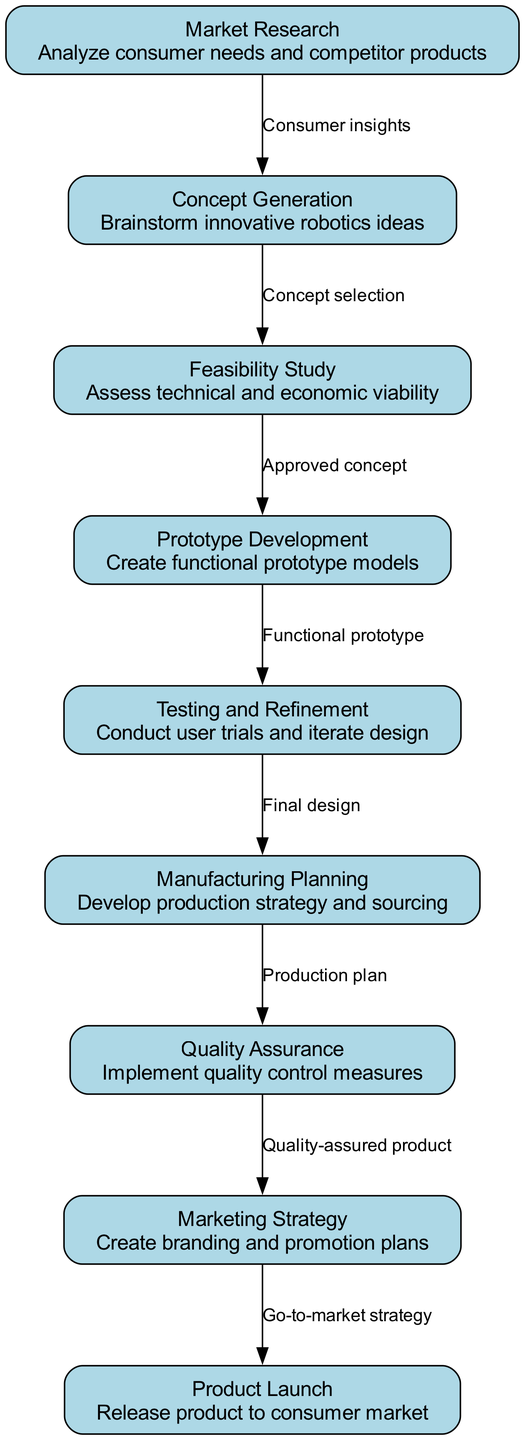What is the first stage of the development lifecycle? The diagram indicates that the first stage in the development lifecycle is labeled as "Market Research," which entails analyzing consumer needs and competitor products.
Answer: Market Research How many nodes are there in the diagram? By counting the individual nodes listed in the diagram, there are a total of 9 distinct nodes representing different stages in the development lifecycle of the consumer robotics product.
Answer: 9 What is the relationship between "Feasibility Study" and "Prototype Development"? The diagram shows a direct edge labeled "Approved concept" connecting "Feasibility Study" to "Prototype Development," indicating that the prototype development follows after an approved concept is established.
Answer: Approved concept Which node comes after "Testing and Refinement"? Following the flow in the diagram, "Testing and Refinement" is connected directly to "Manufacturing Planning," indicating that manufacturing planning occurs next.
Answer: Manufacturing Planning What is the last step before the product is launched? The last step prior to the product launch is "Marketing Strategy," as depicted in the diagram by the directed arrow leading to "Product Launch."
Answer: Marketing Strategy How many edges are present in the diagram? The diagram illustrates the connections between the various nodes, showing a total of 8 directed edges that represent the relationships and flow between the stages of development.
Answer: 8 What does the edge from "Quality Assurance" to "Marketing Strategy" indicate? The edge labeled "Quality-assured product" indicates that a quality-assured product is a prerequisite for developing the marketing strategy for the consumer robotics product.
Answer: Quality-assured product Which two nodes illustrate the progression from design to production? The nodes "Testing and Refinement" and "Manufacturing Planning" illustrate the progression from finalizing the design via testing to planning for production, as represented by the connection in the diagram.
Answer: Testing and Refinement, Manufacturing Planning What key insight is gained from "Market Research"? The edge labeled "Consumer insights" indicates that the key insight derived from "Market Research" is the understanding of consumer needs, which is critical for the next steps in the product development process.
Answer: Consumer insights 